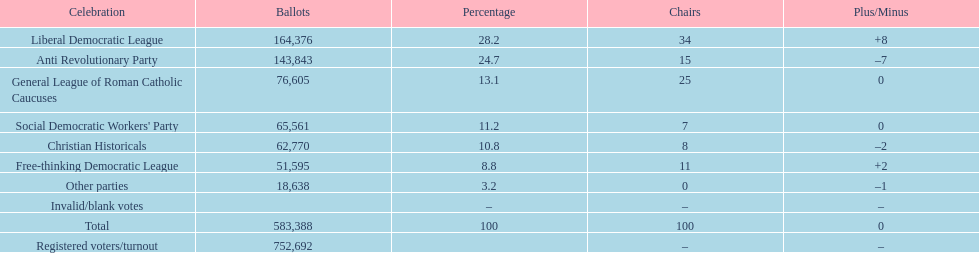Name the top three parties? Liberal Democratic League, Anti Revolutionary Party, General League of Roman Catholic Caucuses. 